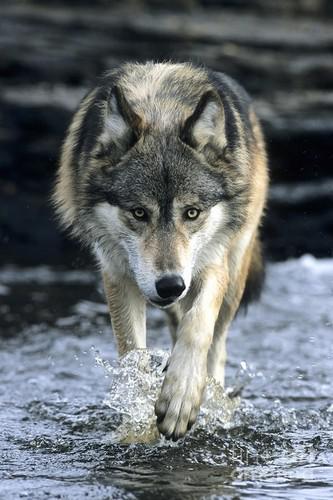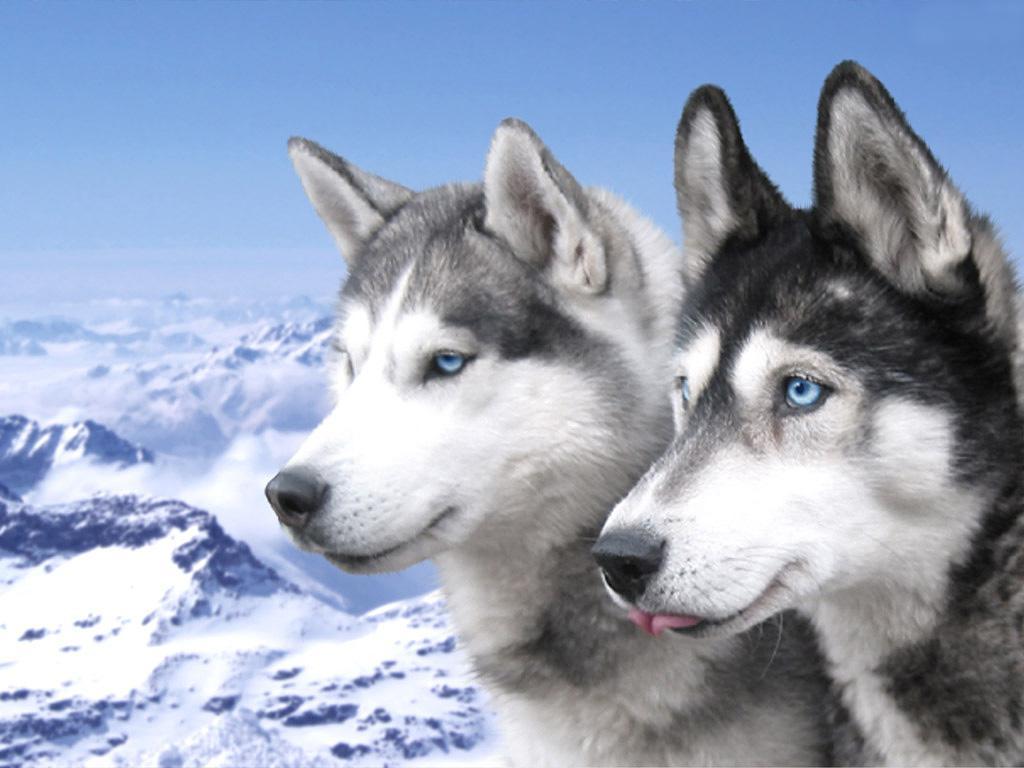The first image is the image on the left, the second image is the image on the right. For the images shown, is this caption "There are 2 wolves facing forward." true? Answer yes or no. No. 